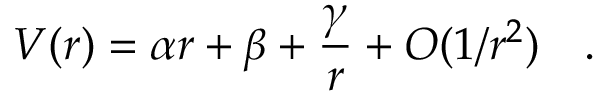<formula> <loc_0><loc_0><loc_500><loc_500>V ( r ) = \alpha r + \beta + { \frac { \gamma } { r } } + O ( 1 / r ^ { 2 } ) \quad .</formula> 